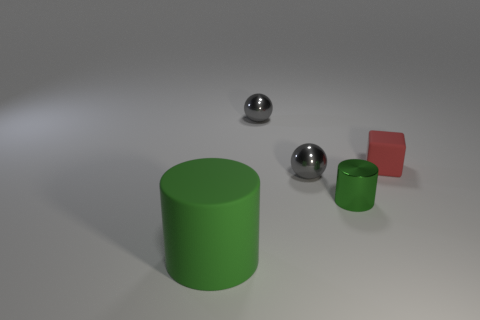Add 2 large rubber objects. How many objects exist? 7 Subtract all spheres. How many objects are left? 3 Subtract 1 cylinders. How many cylinders are left? 1 Subtract all brown cylinders. Subtract all blue cubes. How many cylinders are left? 2 Subtract all brown cylinders. How many purple cubes are left? 0 Subtract all brown metallic cylinders. Subtract all balls. How many objects are left? 3 Add 1 matte blocks. How many matte blocks are left? 2 Add 3 shiny things. How many shiny things exist? 6 Subtract 0 red cylinders. How many objects are left? 5 